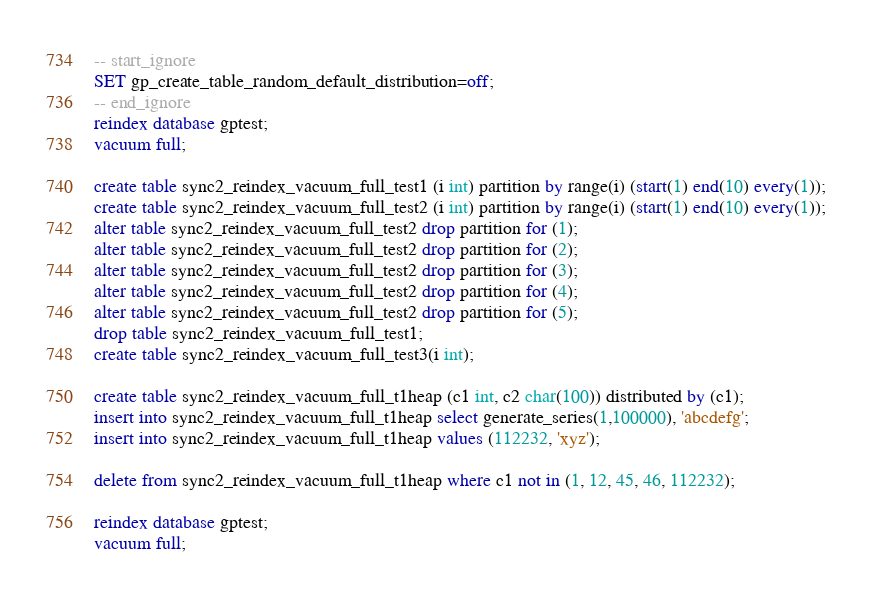<code> <loc_0><loc_0><loc_500><loc_500><_SQL_>-- start_ignore
SET gp_create_table_random_default_distribution=off;
-- end_ignore
reindex database gptest;
vacuum full;

create table sync2_reindex_vacuum_full_test1 (i int) partition by range(i) (start(1) end(10) every(1));
create table sync2_reindex_vacuum_full_test2 (i int) partition by range(i) (start(1) end(10) every(1));
alter table sync2_reindex_vacuum_full_test2 drop partition for (1);
alter table sync2_reindex_vacuum_full_test2 drop partition for (2);
alter table sync2_reindex_vacuum_full_test2 drop partition for (3);
alter table sync2_reindex_vacuum_full_test2 drop partition for (4);
alter table sync2_reindex_vacuum_full_test2 drop partition for (5);
drop table sync2_reindex_vacuum_full_test1;
create table sync2_reindex_vacuum_full_test3(i int);

create table sync2_reindex_vacuum_full_t1heap (c1 int, c2 char(100)) distributed by (c1);
insert into sync2_reindex_vacuum_full_t1heap select generate_series(1,100000), 'abcdefg';
insert into sync2_reindex_vacuum_full_t1heap values (112232, 'xyz');

delete from sync2_reindex_vacuum_full_t1heap where c1 not in (1, 12, 45, 46, 112232);

reindex database gptest;
vacuum full;

</code> 